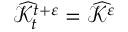Convert formula to latex. <formula><loc_0><loc_0><loc_500><loc_500>\widehat { \mathcal { K } } _ { t } ^ { t + \varepsilon } = \widehat { \mathcal { K } } ^ { \varepsilon }</formula> 